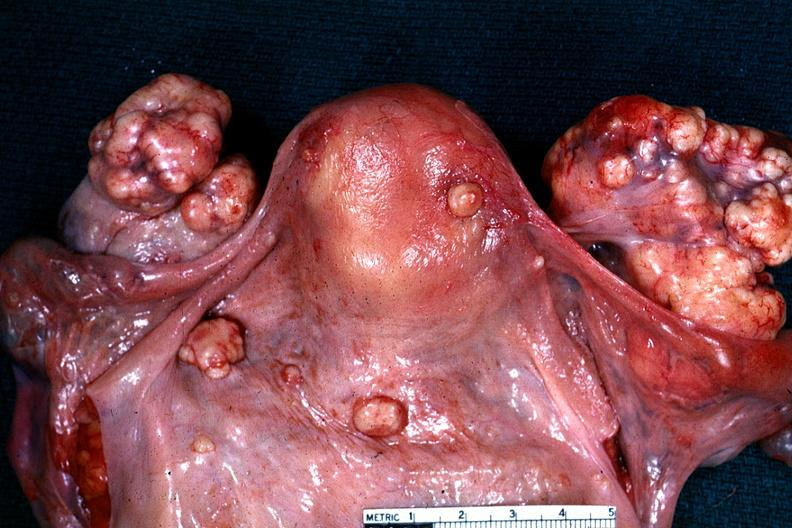where does this belong to?
Answer the question using a single word or phrase. Female reproductive system 